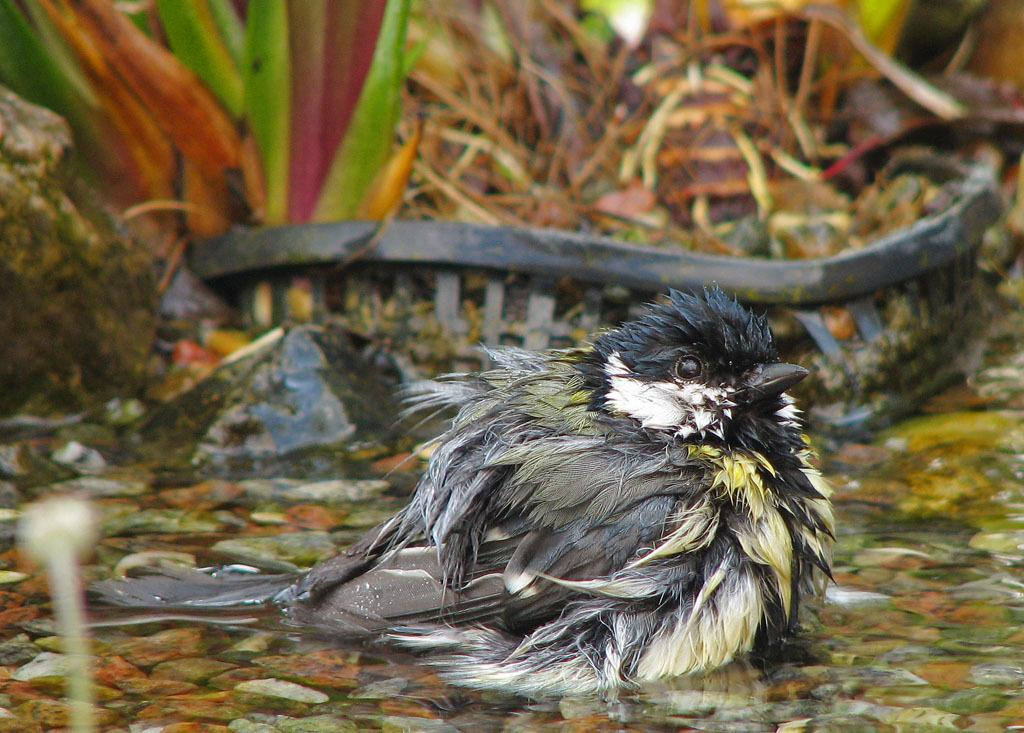What type of animal can be seen in the image? There is a bird in the image. What is the bird situated in? The bird is situated in water. What other elements are present in the image? There are stones in the image. What can be seen in the background of the image? There are plants and some unspecified objects in the background of the image. What type of creature is hiding in the room in the image? There is no room or creature present in the image; it features a bird in water with stones and background elements. 